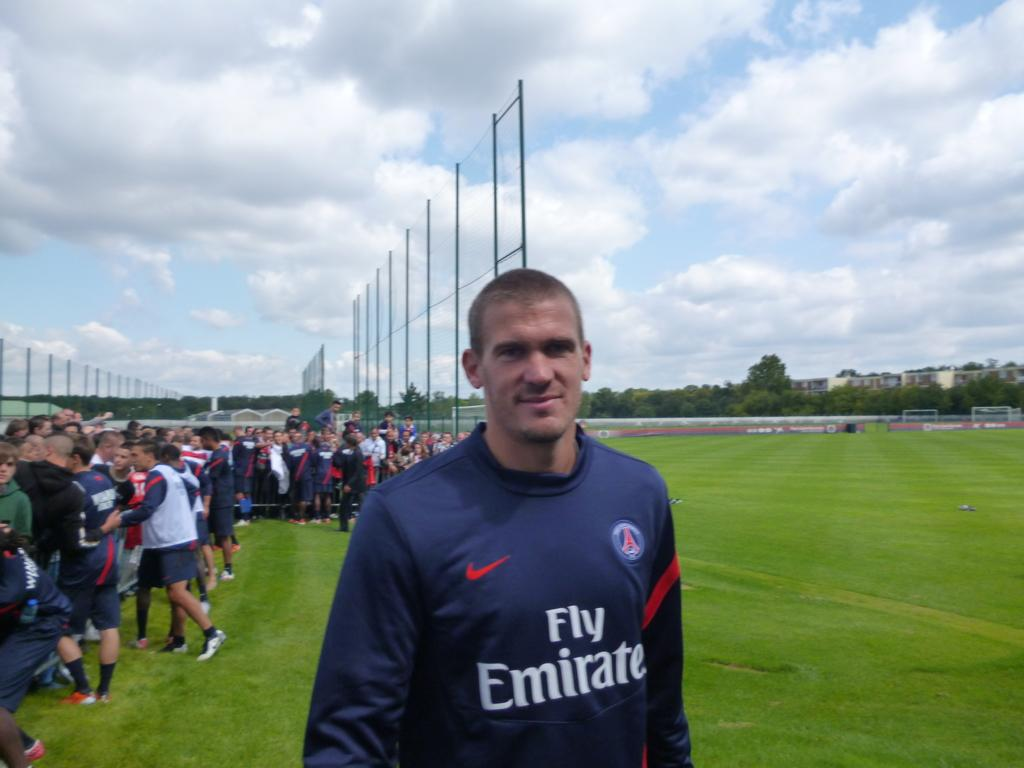What is the main subject of the image? There is a man standing in the image. Where is the man standing? The man is standing on a grassland. Can you describe the background of the image? There are people standing in the background, along with fencing, trees, and the sky. What type of flowers can be seen growing on the ground in the image? There are no flowers visible in the image; the ground is covered by grass. 